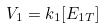Convert formula to latex. <formula><loc_0><loc_0><loc_500><loc_500>V _ { 1 } = k _ { 1 } [ E _ { 1 T } ]</formula> 